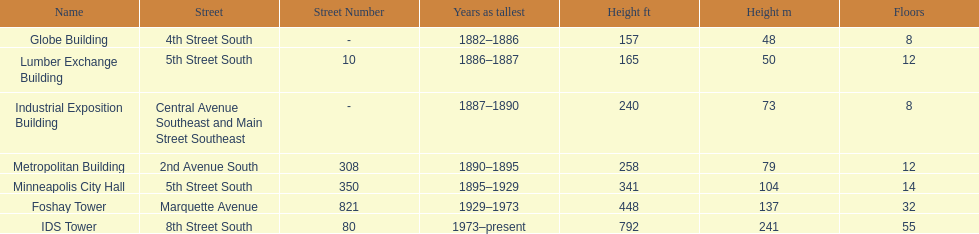Which building has 8 floors and is 240 ft tall? Industrial Exposition Building. 